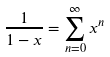<formula> <loc_0><loc_0><loc_500><loc_500>\frac { 1 } { 1 - x } = \sum _ { n = 0 } ^ { \infty } x ^ { n }</formula> 